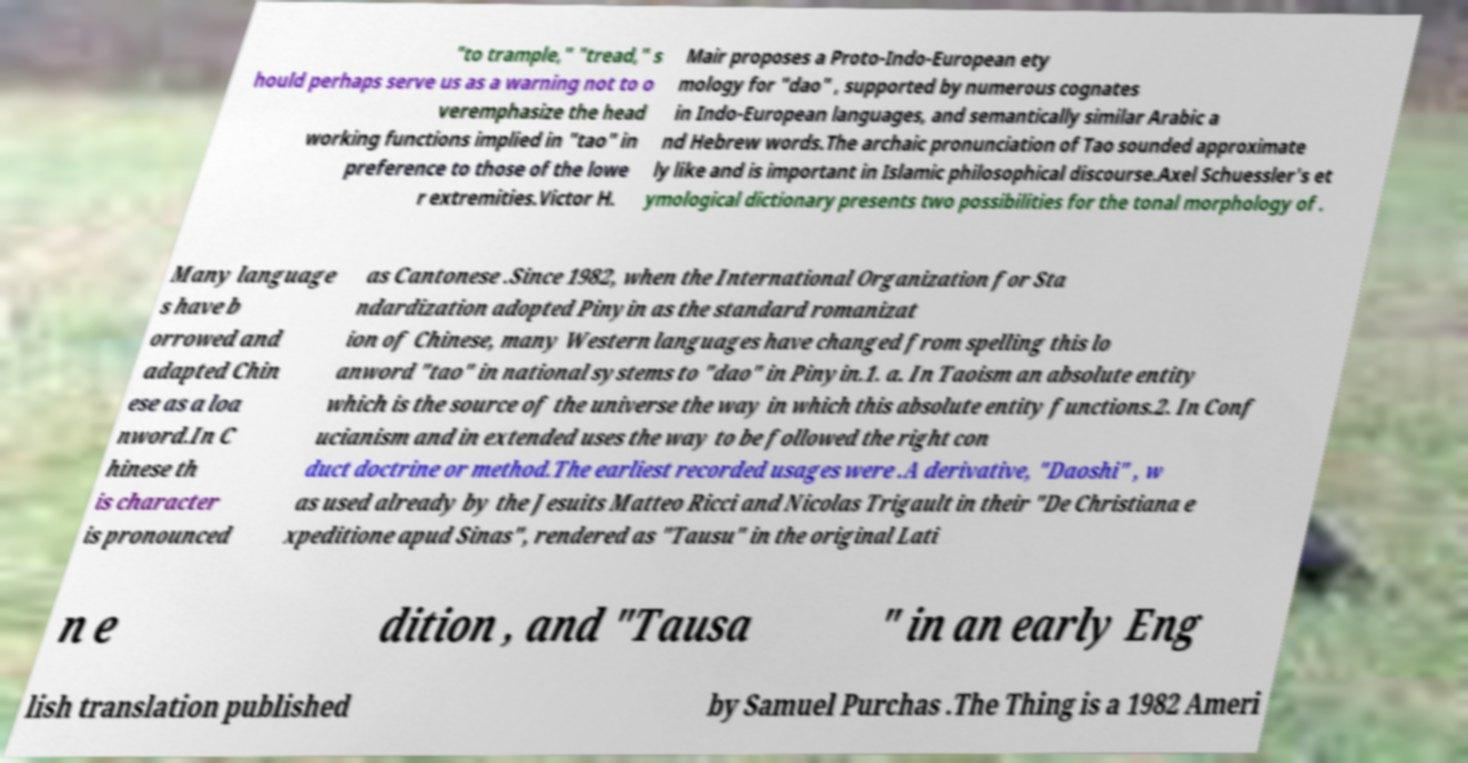Can you accurately transcribe the text from the provided image for me? "to trample," "tread," s hould perhaps serve us as a warning not to o veremphasize the head working functions implied in "tao" in preference to those of the lowe r extremities.Victor H. Mair proposes a Proto-Indo-European ety mology for "dao" , supported by numerous cognates in Indo-European languages, and semantically similar Arabic a nd Hebrew words.The archaic pronunciation of Tao sounded approximate ly like and is important in Islamic philosophical discourse.Axel Schuessler's et ymological dictionary presents two possibilities for the tonal morphology of . Many language s have b orrowed and adapted Chin ese as a loa nword.In C hinese th is character is pronounced as Cantonese .Since 1982, when the International Organization for Sta ndardization adopted Pinyin as the standard romanizat ion of Chinese, many Western languages have changed from spelling this lo anword "tao" in national systems to "dao" in Pinyin.1. a. In Taoism an absolute entity which is the source of the universe the way in which this absolute entity functions.2. In Conf ucianism and in extended uses the way to be followed the right con duct doctrine or method.The earliest recorded usages were .A derivative, "Daoshi" , w as used already by the Jesuits Matteo Ricci and Nicolas Trigault in their "De Christiana e xpeditione apud Sinas", rendered as "Tausu" in the original Lati n e dition , and "Tausa " in an early Eng lish translation published by Samuel Purchas .The Thing is a 1982 Ameri 